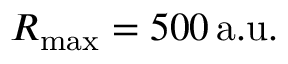<formula> <loc_0><loc_0><loc_500><loc_500>R _ { \max } = 5 0 0 \, a . u .</formula> 